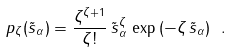Convert formula to latex. <formula><loc_0><loc_0><loc_500><loc_500>p _ { \zeta } ( \tilde { s } _ { \alpha } ) = \frac { \zeta ^ { \zeta + 1 } } { \zeta ! } \, \tilde { s } _ { \alpha } ^ { \zeta } \, \exp \, ( - \zeta \, \tilde { s } _ { \alpha } ) \ .</formula> 